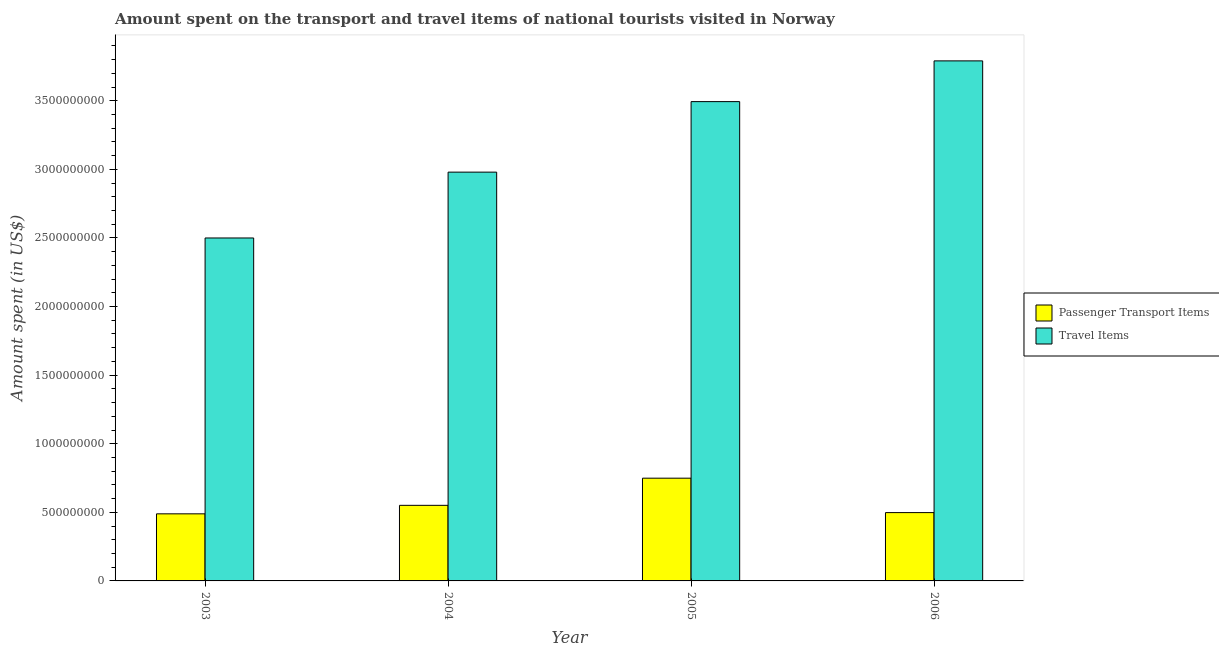How many groups of bars are there?
Make the answer very short. 4. Are the number of bars per tick equal to the number of legend labels?
Make the answer very short. Yes. Are the number of bars on each tick of the X-axis equal?
Provide a succinct answer. Yes. In how many cases, is the number of bars for a given year not equal to the number of legend labels?
Your response must be concise. 0. What is the amount spent in travel items in 2003?
Your response must be concise. 2.50e+09. Across all years, what is the maximum amount spent in travel items?
Give a very brief answer. 3.79e+09. Across all years, what is the minimum amount spent in travel items?
Offer a terse response. 2.50e+09. In which year was the amount spent on passenger transport items maximum?
Provide a short and direct response. 2005. What is the total amount spent on passenger transport items in the graph?
Your response must be concise. 2.29e+09. What is the difference between the amount spent in travel items in 2003 and that in 2006?
Offer a terse response. -1.29e+09. What is the difference between the amount spent in travel items in 2005 and the amount spent on passenger transport items in 2004?
Provide a succinct answer. 5.14e+08. What is the average amount spent in travel items per year?
Offer a terse response. 3.19e+09. In how many years, is the amount spent on passenger transport items greater than 2800000000 US$?
Your answer should be compact. 0. What is the ratio of the amount spent in travel items in 2003 to that in 2004?
Offer a very short reply. 0.84. What is the difference between the highest and the second highest amount spent on passenger transport items?
Keep it short and to the point. 1.98e+08. What is the difference between the highest and the lowest amount spent in travel items?
Offer a very short reply. 1.29e+09. Is the sum of the amount spent on passenger transport items in 2004 and 2006 greater than the maximum amount spent in travel items across all years?
Your answer should be very brief. Yes. What does the 1st bar from the left in 2005 represents?
Offer a very short reply. Passenger Transport Items. What does the 1st bar from the right in 2003 represents?
Keep it short and to the point. Travel Items. How many years are there in the graph?
Provide a succinct answer. 4. What is the difference between two consecutive major ticks on the Y-axis?
Offer a terse response. 5.00e+08. Does the graph contain any zero values?
Make the answer very short. No. What is the title of the graph?
Provide a short and direct response. Amount spent on the transport and travel items of national tourists visited in Norway. What is the label or title of the Y-axis?
Offer a terse response. Amount spent (in US$). What is the Amount spent (in US$) of Passenger Transport Items in 2003?
Your response must be concise. 4.89e+08. What is the Amount spent (in US$) of Travel Items in 2003?
Make the answer very short. 2.50e+09. What is the Amount spent (in US$) of Passenger Transport Items in 2004?
Your answer should be very brief. 5.51e+08. What is the Amount spent (in US$) in Travel Items in 2004?
Give a very brief answer. 2.98e+09. What is the Amount spent (in US$) in Passenger Transport Items in 2005?
Offer a very short reply. 7.49e+08. What is the Amount spent (in US$) of Travel Items in 2005?
Give a very brief answer. 3.49e+09. What is the Amount spent (in US$) in Passenger Transport Items in 2006?
Keep it short and to the point. 4.98e+08. What is the Amount spent (in US$) of Travel Items in 2006?
Provide a short and direct response. 3.79e+09. Across all years, what is the maximum Amount spent (in US$) in Passenger Transport Items?
Your response must be concise. 7.49e+08. Across all years, what is the maximum Amount spent (in US$) of Travel Items?
Offer a terse response. 3.79e+09. Across all years, what is the minimum Amount spent (in US$) of Passenger Transport Items?
Your response must be concise. 4.89e+08. Across all years, what is the minimum Amount spent (in US$) of Travel Items?
Provide a short and direct response. 2.50e+09. What is the total Amount spent (in US$) in Passenger Transport Items in the graph?
Your answer should be compact. 2.29e+09. What is the total Amount spent (in US$) of Travel Items in the graph?
Your response must be concise. 1.28e+1. What is the difference between the Amount spent (in US$) in Passenger Transport Items in 2003 and that in 2004?
Give a very brief answer. -6.20e+07. What is the difference between the Amount spent (in US$) of Travel Items in 2003 and that in 2004?
Ensure brevity in your answer.  -4.80e+08. What is the difference between the Amount spent (in US$) of Passenger Transport Items in 2003 and that in 2005?
Your answer should be very brief. -2.60e+08. What is the difference between the Amount spent (in US$) of Travel Items in 2003 and that in 2005?
Offer a very short reply. -9.94e+08. What is the difference between the Amount spent (in US$) in Passenger Transport Items in 2003 and that in 2006?
Provide a succinct answer. -9.00e+06. What is the difference between the Amount spent (in US$) in Travel Items in 2003 and that in 2006?
Your answer should be very brief. -1.29e+09. What is the difference between the Amount spent (in US$) in Passenger Transport Items in 2004 and that in 2005?
Provide a short and direct response. -1.98e+08. What is the difference between the Amount spent (in US$) of Travel Items in 2004 and that in 2005?
Give a very brief answer. -5.14e+08. What is the difference between the Amount spent (in US$) of Passenger Transport Items in 2004 and that in 2006?
Ensure brevity in your answer.  5.30e+07. What is the difference between the Amount spent (in US$) in Travel Items in 2004 and that in 2006?
Give a very brief answer. -8.11e+08. What is the difference between the Amount spent (in US$) of Passenger Transport Items in 2005 and that in 2006?
Make the answer very short. 2.51e+08. What is the difference between the Amount spent (in US$) of Travel Items in 2005 and that in 2006?
Keep it short and to the point. -2.97e+08. What is the difference between the Amount spent (in US$) in Passenger Transport Items in 2003 and the Amount spent (in US$) in Travel Items in 2004?
Make the answer very short. -2.49e+09. What is the difference between the Amount spent (in US$) of Passenger Transport Items in 2003 and the Amount spent (in US$) of Travel Items in 2005?
Your answer should be compact. -3.00e+09. What is the difference between the Amount spent (in US$) in Passenger Transport Items in 2003 and the Amount spent (in US$) in Travel Items in 2006?
Provide a succinct answer. -3.30e+09. What is the difference between the Amount spent (in US$) of Passenger Transport Items in 2004 and the Amount spent (in US$) of Travel Items in 2005?
Keep it short and to the point. -2.94e+09. What is the difference between the Amount spent (in US$) in Passenger Transport Items in 2004 and the Amount spent (in US$) in Travel Items in 2006?
Provide a short and direct response. -3.24e+09. What is the difference between the Amount spent (in US$) of Passenger Transport Items in 2005 and the Amount spent (in US$) of Travel Items in 2006?
Your answer should be very brief. -3.04e+09. What is the average Amount spent (in US$) in Passenger Transport Items per year?
Make the answer very short. 5.72e+08. What is the average Amount spent (in US$) of Travel Items per year?
Keep it short and to the point. 3.19e+09. In the year 2003, what is the difference between the Amount spent (in US$) of Passenger Transport Items and Amount spent (in US$) of Travel Items?
Give a very brief answer. -2.01e+09. In the year 2004, what is the difference between the Amount spent (in US$) in Passenger Transport Items and Amount spent (in US$) in Travel Items?
Provide a succinct answer. -2.43e+09. In the year 2005, what is the difference between the Amount spent (in US$) in Passenger Transport Items and Amount spent (in US$) in Travel Items?
Offer a very short reply. -2.74e+09. In the year 2006, what is the difference between the Amount spent (in US$) in Passenger Transport Items and Amount spent (in US$) in Travel Items?
Ensure brevity in your answer.  -3.29e+09. What is the ratio of the Amount spent (in US$) of Passenger Transport Items in 2003 to that in 2004?
Make the answer very short. 0.89. What is the ratio of the Amount spent (in US$) in Travel Items in 2003 to that in 2004?
Your answer should be compact. 0.84. What is the ratio of the Amount spent (in US$) in Passenger Transport Items in 2003 to that in 2005?
Give a very brief answer. 0.65. What is the ratio of the Amount spent (in US$) in Travel Items in 2003 to that in 2005?
Make the answer very short. 0.72. What is the ratio of the Amount spent (in US$) in Passenger Transport Items in 2003 to that in 2006?
Offer a terse response. 0.98. What is the ratio of the Amount spent (in US$) of Travel Items in 2003 to that in 2006?
Give a very brief answer. 0.66. What is the ratio of the Amount spent (in US$) in Passenger Transport Items in 2004 to that in 2005?
Offer a terse response. 0.74. What is the ratio of the Amount spent (in US$) of Travel Items in 2004 to that in 2005?
Your answer should be compact. 0.85. What is the ratio of the Amount spent (in US$) of Passenger Transport Items in 2004 to that in 2006?
Keep it short and to the point. 1.11. What is the ratio of the Amount spent (in US$) in Travel Items in 2004 to that in 2006?
Offer a very short reply. 0.79. What is the ratio of the Amount spent (in US$) in Passenger Transport Items in 2005 to that in 2006?
Offer a very short reply. 1.5. What is the ratio of the Amount spent (in US$) in Travel Items in 2005 to that in 2006?
Your answer should be very brief. 0.92. What is the difference between the highest and the second highest Amount spent (in US$) of Passenger Transport Items?
Give a very brief answer. 1.98e+08. What is the difference between the highest and the second highest Amount spent (in US$) in Travel Items?
Make the answer very short. 2.97e+08. What is the difference between the highest and the lowest Amount spent (in US$) of Passenger Transport Items?
Make the answer very short. 2.60e+08. What is the difference between the highest and the lowest Amount spent (in US$) in Travel Items?
Your answer should be compact. 1.29e+09. 